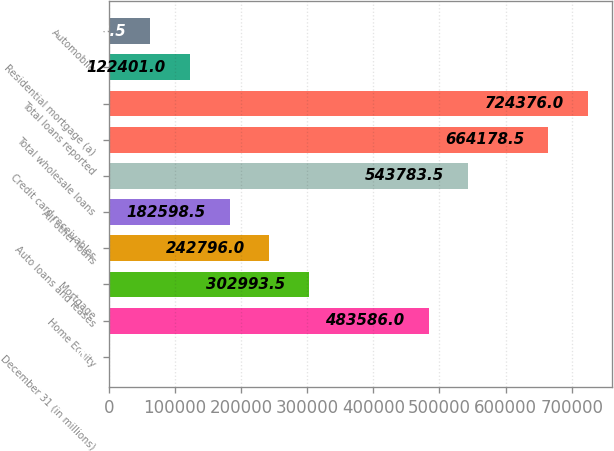<chart> <loc_0><loc_0><loc_500><loc_500><bar_chart><fcel>December 31 (in millions)<fcel>Home Equity<fcel>Mortgage<fcel>Auto loans and leases<fcel>All other loans<fcel>Credit card receivables<fcel>Total wholesale loans<fcel>Total loans reported<fcel>Residential mortgage (a)<fcel>Automobile<nl><fcel>2006<fcel>483586<fcel>302994<fcel>242796<fcel>182598<fcel>543784<fcel>664178<fcel>724376<fcel>122401<fcel>62203.5<nl></chart> 